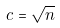Convert formula to latex. <formula><loc_0><loc_0><loc_500><loc_500>c = \sqrt { n }</formula> 